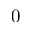<formula> <loc_0><loc_0><loc_500><loc_500>0</formula> 